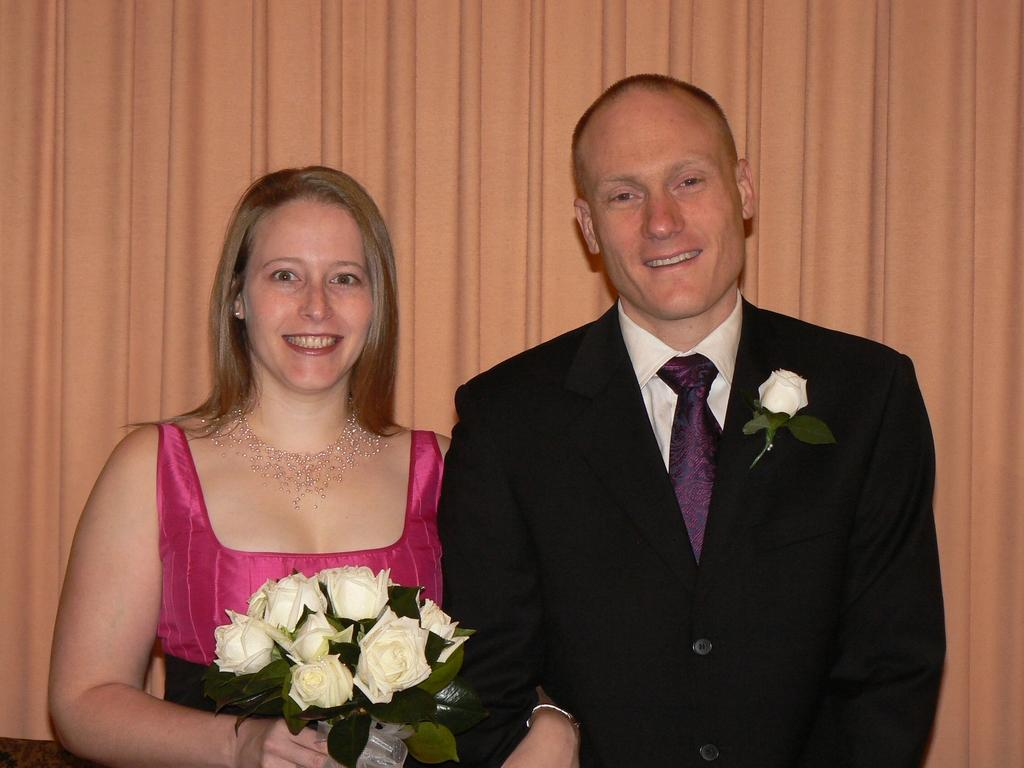Where was the image taken? The image was taken indoors. What can be seen in the background of the image? There is a curtain in the background of the image. Who are the people in the image? A man and a woman are standing in the middle of the image. What is the woman holding in her hand? The woman is holding a bouquet in her hand. What is the tail of the cat in the image? There is no cat present in the image, so there is no tail to describe. 